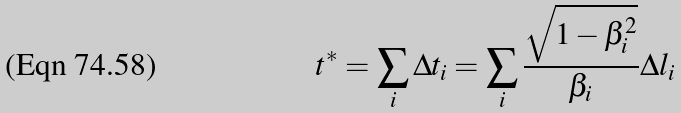Convert formula to latex. <formula><loc_0><loc_0><loc_500><loc_500>t ^ { * } = \sum _ { i } \Delta t _ { i } = \sum _ { i } \frac { \sqrt { 1 - \beta ^ { 2 } _ { i } } } { \beta _ { i } } \Delta l _ { i }</formula> 